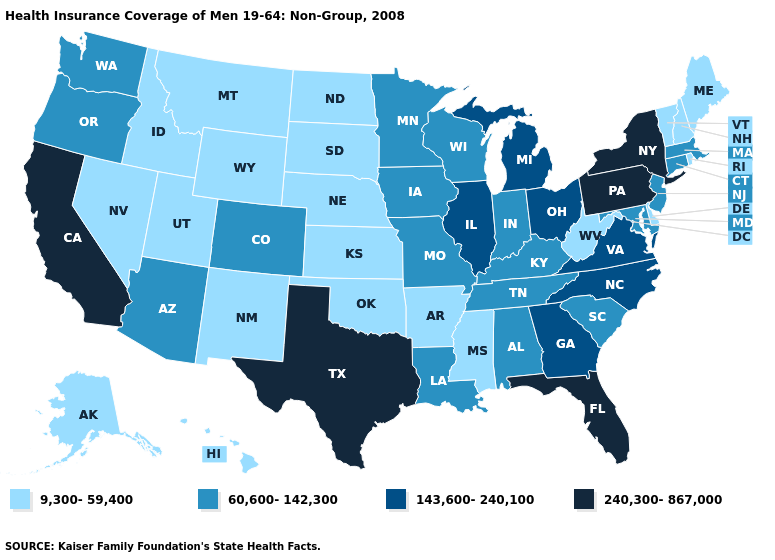Which states hav the highest value in the West?
Be succinct. California. Does Kentucky have the highest value in the USA?
Concise answer only. No. What is the value of South Dakota?
Keep it brief. 9,300-59,400. What is the value of Louisiana?
Be succinct. 60,600-142,300. Name the states that have a value in the range 9,300-59,400?
Give a very brief answer. Alaska, Arkansas, Delaware, Hawaii, Idaho, Kansas, Maine, Mississippi, Montana, Nebraska, Nevada, New Hampshire, New Mexico, North Dakota, Oklahoma, Rhode Island, South Dakota, Utah, Vermont, West Virginia, Wyoming. Name the states that have a value in the range 240,300-867,000?
Answer briefly. California, Florida, New York, Pennsylvania, Texas. What is the value of Minnesota?
Write a very short answer. 60,600-142,300. Which states have the lowest value in the West?
Be succinct. Alaska, Hawaii, Idaho, Montana, Nevada, New Mexico, Utah, Wyoming. Does Kentucky have the highest value in the USA?
Quick response, please. No. What is the highest value in the West ?
Answer briefly. 240,300-867,000. What is the value of Michigan?
Concise answer only. 143,600-240,100. What is the highest value in the South ?
Keep it brief. 240,300-867,000. Does the map have missing data?
Give a very brief answer. No. Does Nevada have a lower value than Connecticut?
Answer briefly. Yes. 